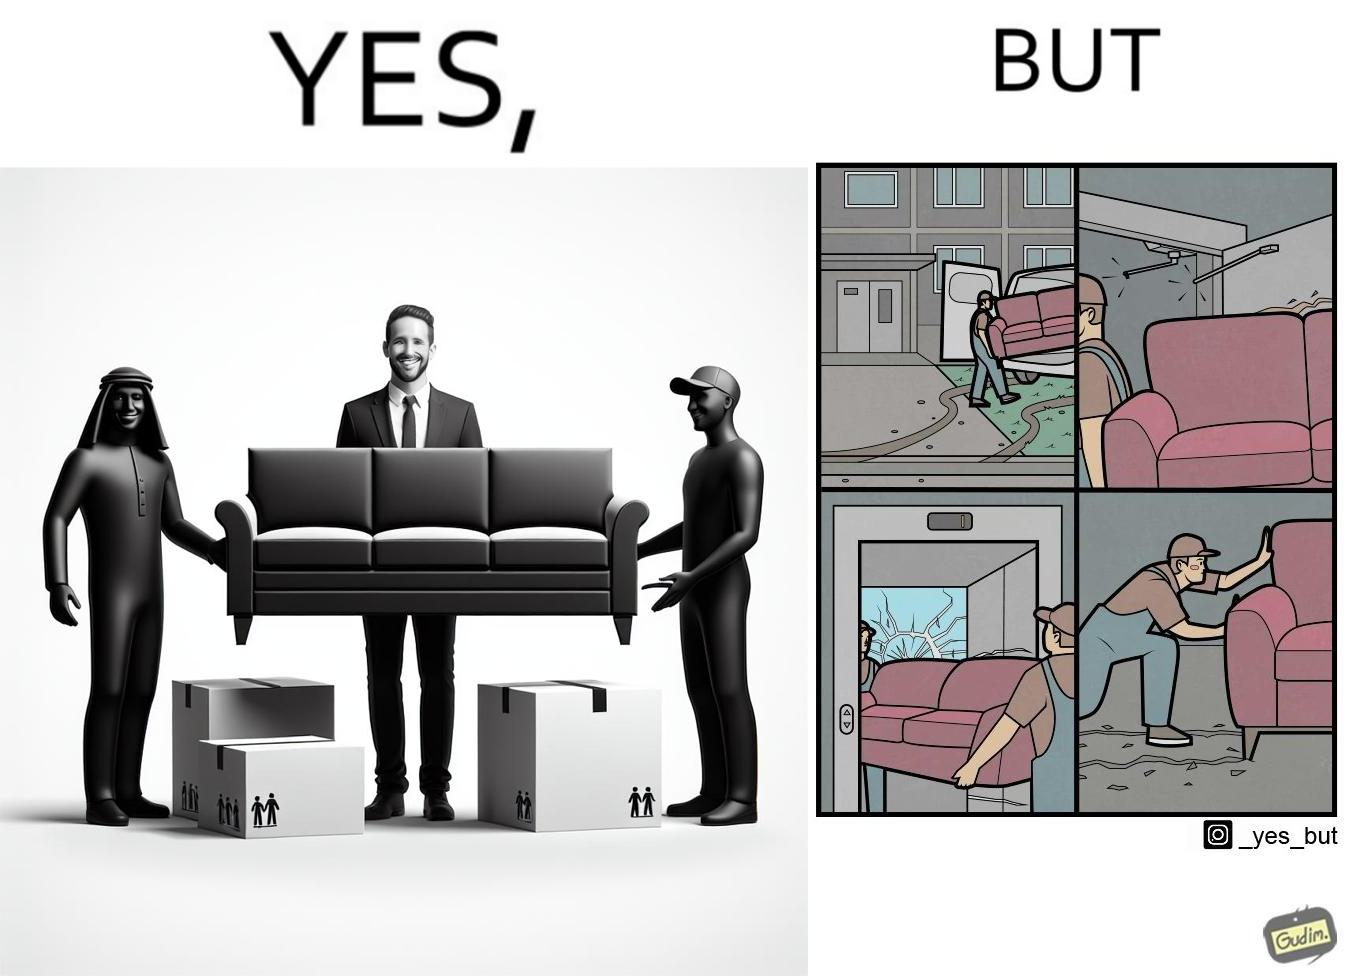Explain why this image is satirical. The images are funny since they show how even though the hired movers achieve their task of moving in furniture, in the process, the cause damage to the whole house 